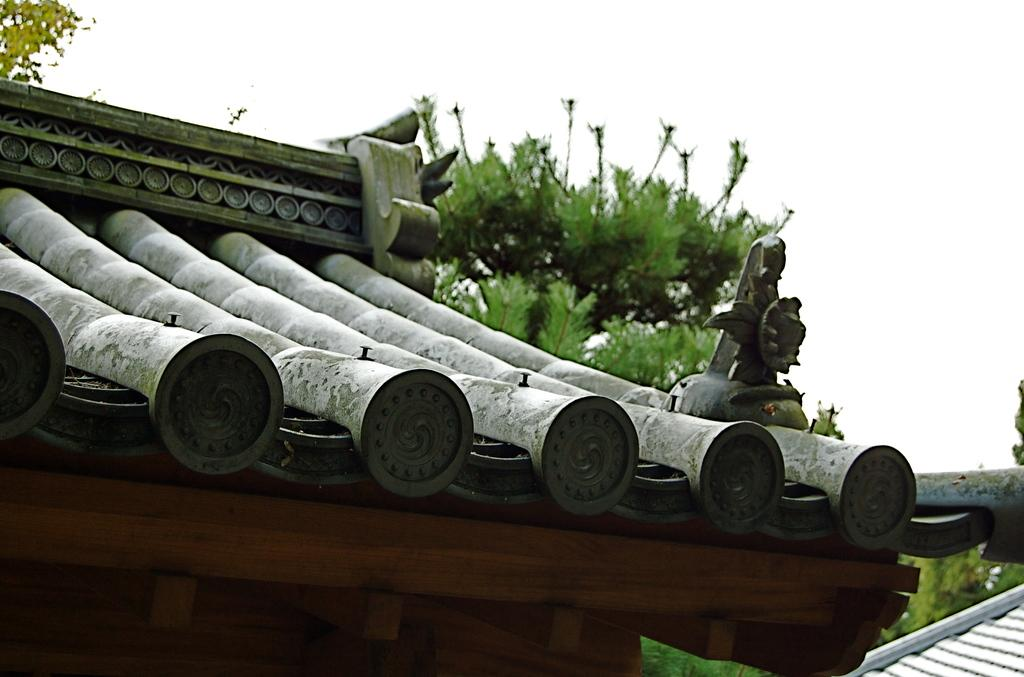What is present on top of the structure in the image? There is a roof in the image, and it has wooden rods. What other features can be seen on the roof? There are pipe-like structures on the roof. What can be seen in the background of the image? There is a tree and the sky visible in the background of the image. How many chairs are placed in the middle of the roof in the image? There are no chairs present in the image, and the roof does not have a middle section. 